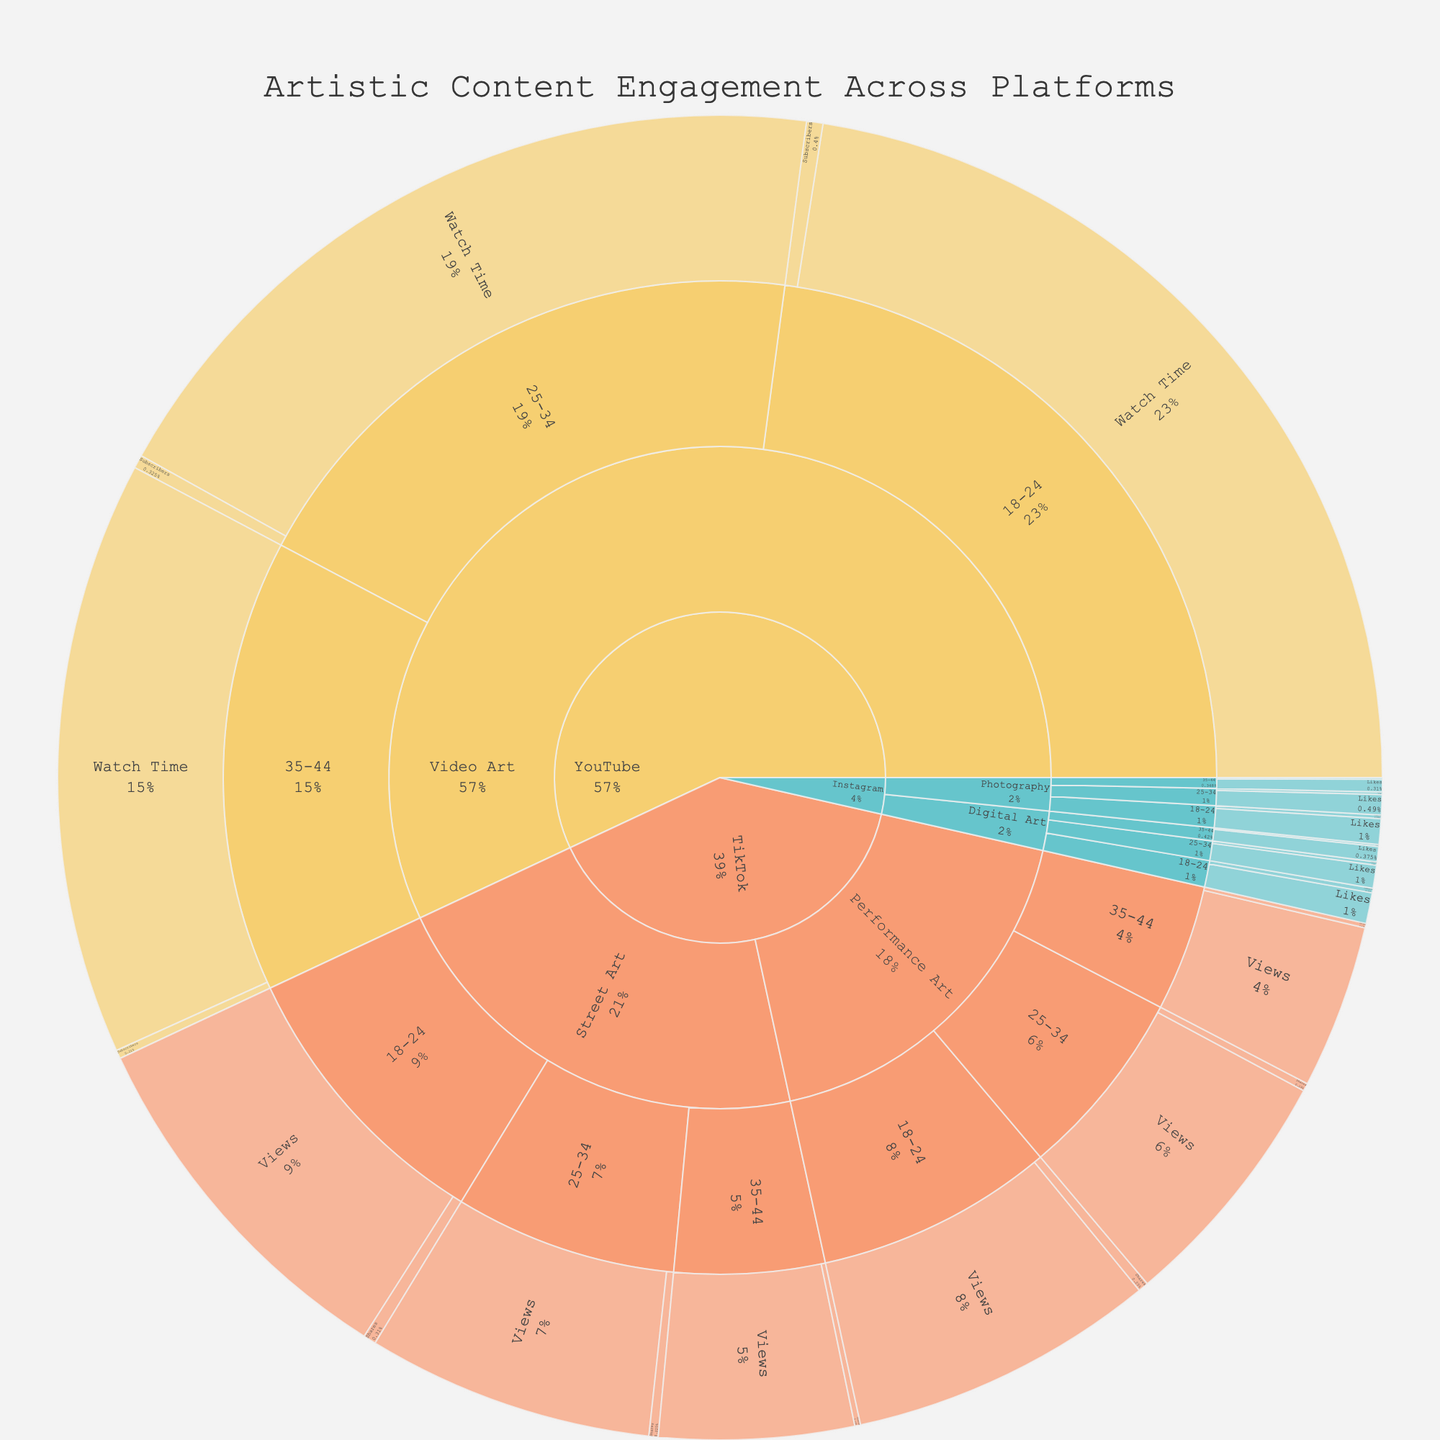What is the title of the Sunburst Plot? The title of the plot is displayed at the top center of the figure. It reads "Artistic Content Engagement Across Platforms".
Answer: Artistic Content Engagement Across Platforms Which platform has the highest engagement value for 18-24 age group Photography content in terms of Likes? By tracing the path 'Instagram' -> 'Photography' -> '18-24' -> 'Likes', we can identify the engagement metric as 12,500 Likes, which is the highest for this category.
Answer: Instagram What is the difference in the number of Likes between Digital Art and Photography on Instagram for the 25-34 age group? First, locate 'Instagram' -> 'Digital Art' -> '25-34' -> 'Likes', which is 11,200 Likes. Then find 'Instagram' -> 'Photography' -> '25-34' -> 'Likes', which is 9,800 Likes. The difference is 11,200 - 9,800 = 1,400 Likes.
Answer: 1,400 Which content type has the highest number of Shares on TikTok for the 18-24 age group? Look under TikTok and explore 'Performance Art' and 'Street Art' paths for the 18-24 age group. Performance Art has 5,000 Shares, while Street Art has 6,200 Shares. Therefore, Street Art has the highest number of Shares.
Answer: Street Art What composition of content type and engagement metric has the highest value on YouTube for the 18-24 age group? Navigate to YouTube and explore 'Video Art' for the 18-24 age group. Compare 'Watch Time' (450,000) and 'Subscribers' (8,000). Watch Time has the highest value.
Answer: Watch Time Which age group has the lowest views for Street Art on TikTok? Under TikTok -> Street Art, compare the views: 18-24 (180,000), 25-34 (140,000), and 35-44 (95,000). The 35-44 age group has the lowest views at 95,000.
Answer: 35-44 What is the total number of Comments for Photography content on Instagram across all age groups? Navigate to Instagram -> Photography and sum the Comments: 1,800 (18-24) + 1,200 (25-34) + 750 (35-44) = 3,750 Comments.
Answer: 3,750 How do the total number of Shares for Performance Art and Street Art compare on TikTok for the 25-34 age group? Add the Shares for both content types in TikTok for the 25-34 age group. Performance Art has 3,800 Shares, and Street Art has 4,500 Shares. Street Art has more Shares than Performance Art by 4,500 - 3,800 = 700.
Answer: Street Art has 700 more Shares What platform and engagement type have the highest overall numerical value for any content type? Traverse through all platform pathways to compare engagement values. The highest overall value found is on YouTube -> Video Art -> 18-24 -> Watch Time with 450,000.
Answer: YouTube, Watch Time What is the average number of Likes for Digital Art on Instagram across all age groups? For Digital Art on Instagram, sum the Likes values (15,000 + 11,200 + 7,500) and divide by the number of age groups (3), which is (15,000 + 11,200 + 7,500) / 3 = 33,700 / 3 ≈ 11,233.33.
Answer: 11,233.33 